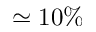Convert formula to latex. <formula><loc_0><loc_0><loc_500><loc_500>\simeq 1 0 \%</formula> 